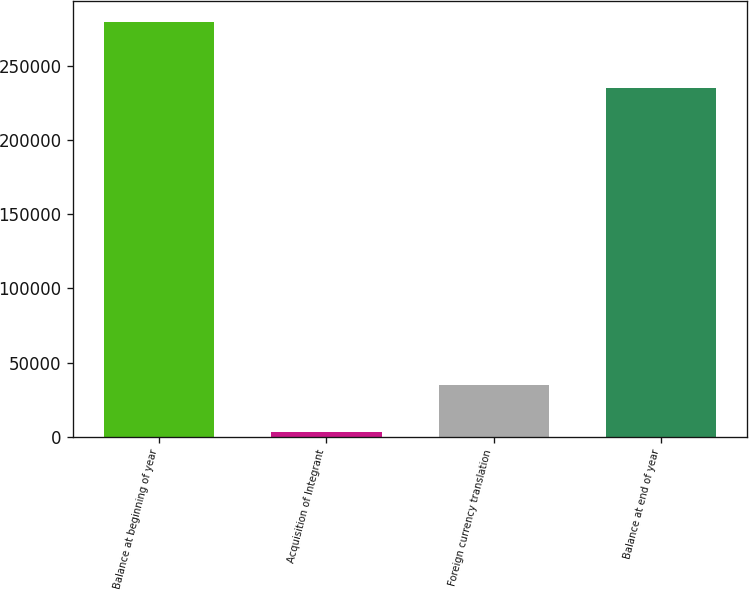<chart> <loc_0><loc_0><loc_500><loc_500><bar_chart><fcel>Balance at beginning of year<fcel>Acquisition of Integrant<fcel>Foreign currency translation<fcel>Balance at end of year<nl><fcel>279469<fcel>2988<fcel>34633<fcel>235175<nl></chart> 